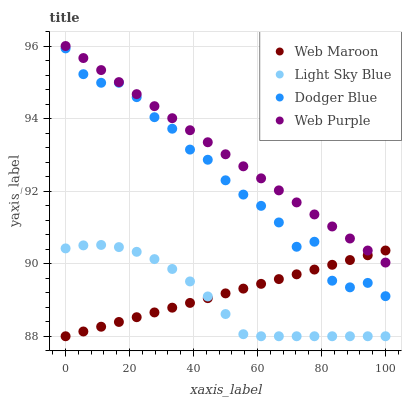Does Light Sky Blue have the minimum area under the curve?
Answer yes or no. Yes. Does Web Purple have the maximum area under the curve?
Answer yes or no. Yes. Does Web Purple have the minimum area under the curve?
Answer yes or no. No. Does Light Sky Blue have the maximum area under the curve?
Answer yes or no. No. Is Web Maroon the smoothest?
Answer yes or no. Yes. Is Dodger Blue the roughest?
Answer yes or no. Yes. Is Web Purple the smoothest?
Answer yes or no. No. Is Web Purple the roughest?
Answer yes or no. No. Does Light Sky Blue have the lowest value?
Answer yes or no. Yes. Does Web Purple have the lowest value?
Answer yes or no. No. Does Web Purple have the highest value?
Answer yes or no. Yes. Does Light Sky Blue have the highest value?
Answer yes or no. No. Is Dodger Blue less than Web Purple?
Answer yes or no. Yes. Is Web Purple greater than Dodger Blue?
Answer yes or no. Yes. Does Web Maroon intersect Dodger Blue?
Answer yes or no. Yes. Is Web Maroon less than Dodger Blue?
Answer yes or no. No. Is Web Maroon greater than Dodger Blue?
Answer yes or no. No. Does Dodger Blue intersect Web Purple?
Answer yes or no. No. 